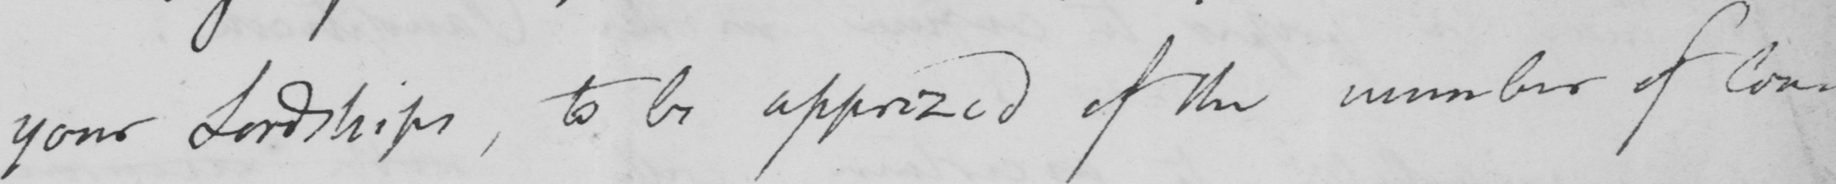Can you tell me what this handwritten text says? your Lordships, to be apprized of the number of Con- 